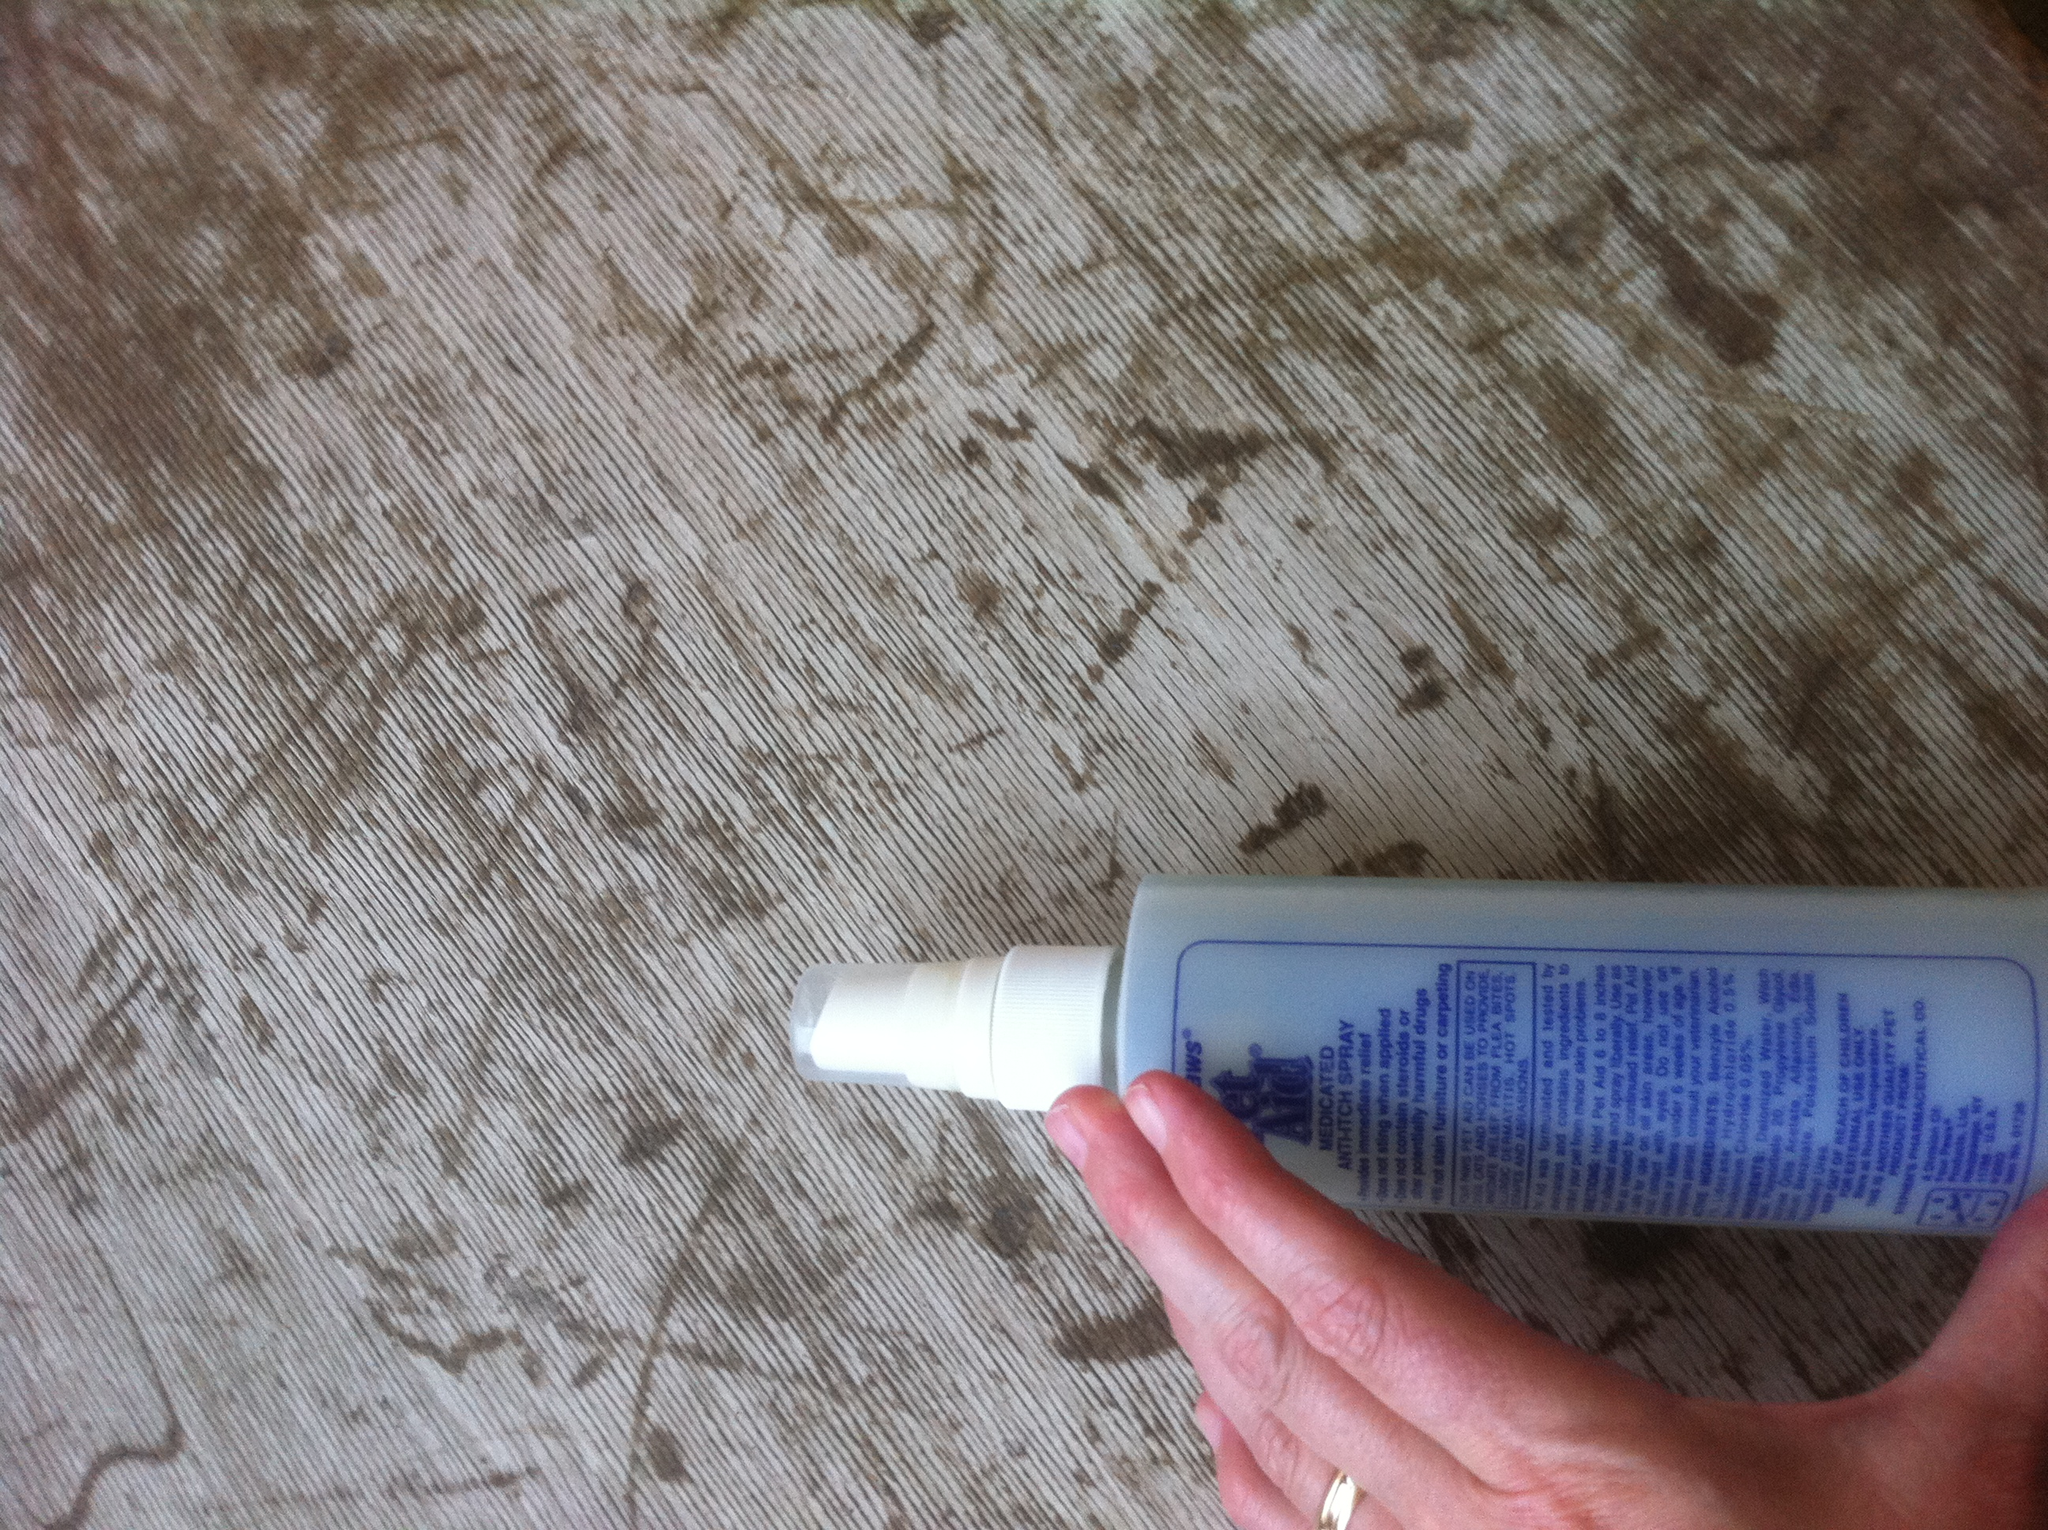What scenario could lead to needing this product for your dog? One realistic scenario is that your dog might develop a skin rash after playing in a grassy field with allergens. You would need this product to provide relief from the itching and soothe the irritated skin. What are some long-term benefits of regularly using this product? Regular use of this product can contribute to long-term benefits such as maintaining a healthy and shiny coat, preventing common skin issues like dryness, rashes, and hot spots, and generally improving your pet’s comfort and well-being. Additionally, it can act as a preventive measure against fleas and other pests, ensuring your dog stays healthy and less prone to allergy-related scratching. 